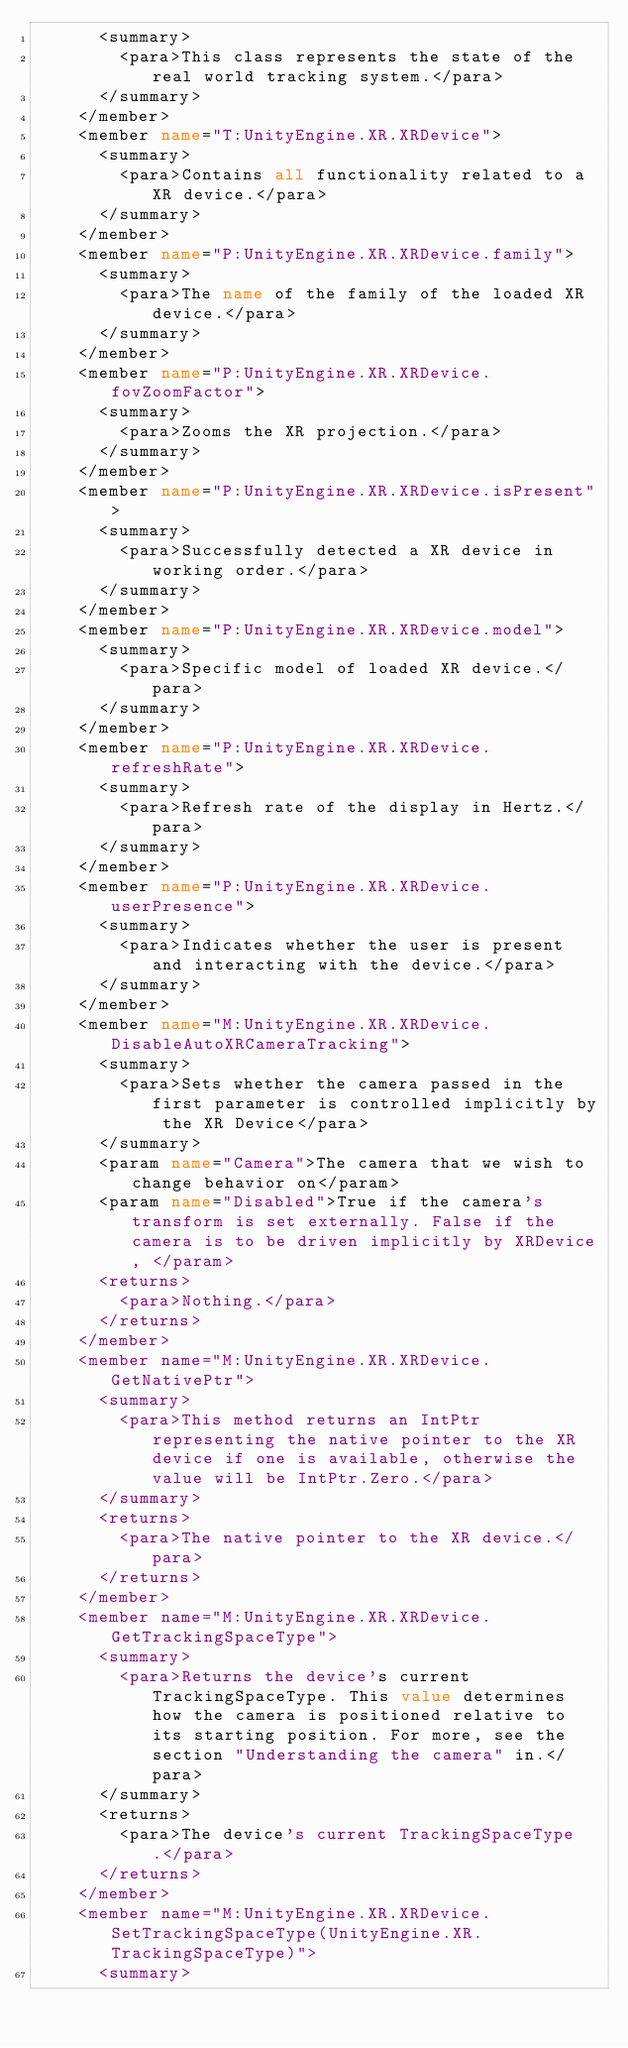<code> <loc_0><loc_0><loc_500><loc_500><_XML_>      <summary>
        <para>This class represents the state of the real world tracking system.</para>
      </summary>
    </member>
    <member name="T:UnityEngine.XR.XRDevice">
      <summary>
        <para>Contains all functionality related to a XR device.</para>
      </summary>
    </member>
    <member name="P:UnityEngine.XR.XRDevice.family">
      <summary>
        <para>The name of the family of the loaded XR device.</para>
      </summary>
    </member>
    <member name="P:UnityEngine.XR.XRDevice.fovZoomFactor">
      <summary>
        <para>Zooms the XR projection.</para>
      </summary>
    </member>
    <member name="P:UnityEngine.XR.XRDevice.isPresent">
      <summary>
        <para>Successfully detected a XR device in working order.</para>
      </summary>
    </member>
    <member name="P:UnityEngine.XR.XRDevice.model">
      <summary>
        <para>Specific model of loaded XR device.</para>
      </summary>
    </member>
    <member name="P:UnityEngine.XR.XRDevice.refreshRate">
      <summary>
        <para>Refresh rate of the display in Hertz.</para>
      </summary>
    </member>
    <member name="P:UnityEngine.XR.XRDevice.userPresence">
      <summary>
        <para>Indicates whether the user is present and interacting with the device.</para>
      </summary>
    </member>
    <member name="M:UnityEngine.XR.XRDevice.DisableAutoXRCameraTracking">
      <summary>
        <para>Sets whether the camera passed in the first parameter is controlled implicitly by the XR Device</para>
      </summary>
      <param name="Camera">The camera that we wish to change behavior on</param>
      <param name="Disabled">True if the camera's transform is set externally. False if the camera is to be driven implicitly by XRDevice, </param>
      <returns>
        <para>Nothing.</para>
      </returns>
    </member>
    <member name="M:UnityEngine.XR.XRDevice.GetNativePtr">
      <summary>
        <para>This method returns an IntPtr representing the native pointer to the XR device if one is available, otherwise the value will be IntPtr.Zero.</para>
      </summary>
      <returns>
        <para>The native pointer to the XR device.</para>
      </returns>
    </member>
    <member name="M:UnityEngine.XR.XRDevice.GetTrackingSpaceType">
      <summary>
        <para>Returns the device's current TrackingSpaceType. This value determines how the camera is positioned relative to its starting position. For more, see the section "Understanding the camera" in.</para>
      </summary>
      <returns>
        <para>The device's current TrackingSpaceType.</para>
      </returns>
    </member>
    <member name="M:UnityEngine.XR.XRDevice.SetTrackingSpaceType(UnityEngine.XR.TrackingSpaceType)">
      <summary></code> 